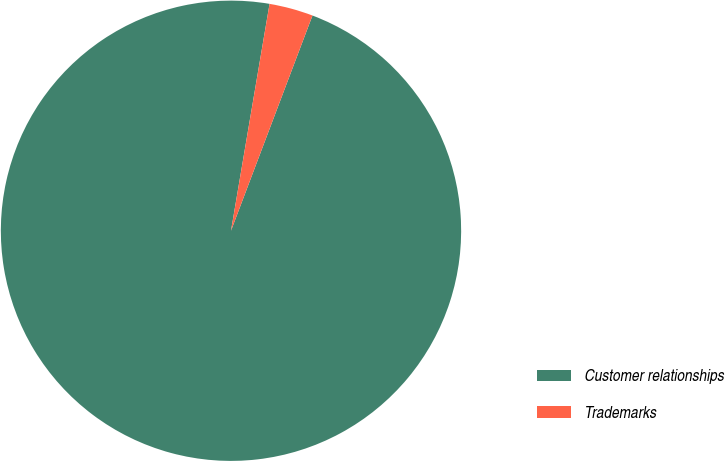Convert chart to OTSL. <chart><loc_0><loc_0><loc_500><loc_500><pie_chart><fcel>Customer relationships<fcel>Trademarks<nl><fcel>96.92%<fcel>3.08%<nl></chart> 